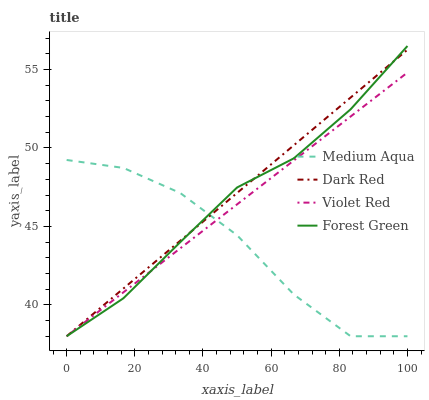Does Medium Aqua have the minimum area under the curve?
Answer yes or no. Yes. Does Dark Red have the maximum area under the curve?
Answer yes or no. Yes. Does Violet Red have the minimum area under the curve?
Answer yes or no. No. Does Violet Red have the maximum area under the curve?
Answer yes or no. No. Is Violet Red the smoothest?
Answer yes or no. Yes. Is Medium Aqua the roughest?
Answer yes or no. Yes. Is Medium Aqua the smoothest?
Answer yes or no. No. Is Violet Red the roughest?
Answer yes or no. No. Does Dark Red have the lowest value?
Answer yes or no. Yes. Does Forest Green have the highest value?
Answer yes or no. Yes. Does Violet Red have the highest value?
Answer yes or no. No. Does Dark Red intersect Forest Green?
Answer yes or no. Yes. Is Dark Red less than Forest Green?
Answer yes or no. No. Is Dark Red greater than Forest Green?
Answer yes or no. No. 